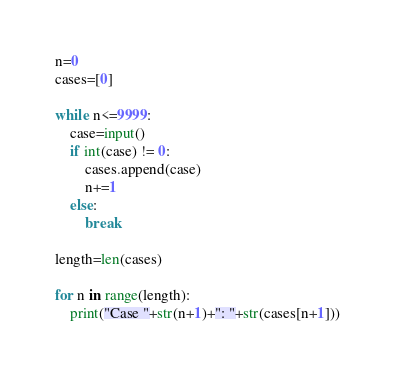<code> <loc_0><loc_0><loc_500><loc_500><_Python_>n=0
cases=[0]

while n<=9999:
    case=input()
    if int(case) != 0:
        cases.append(case)
        n+=1
    else:
        break

length=len(cases)

for n in range(length):
    print("Case "+str(n+1)+": "+str(cases[n+1]))</code> 